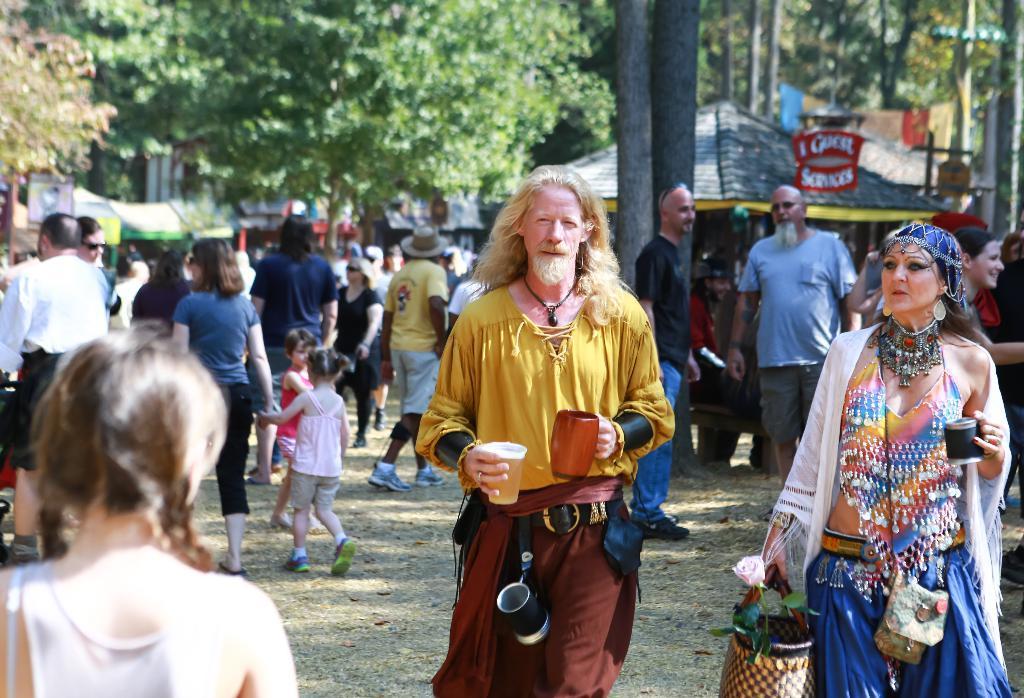In one or two sentences, can you explain what this image depicts? In this picture I can see few people standing and few are walking and I can see a man holding a jug and a glass in his hands and I can see a woman standing on the side and holding a cup and a basket and I can see few stores in the back and a board with some text and I can see trees. 